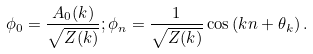Convert formula to latex. <formula><loc_0><loc_0><loc_500><loc_500>\phi _ { 0 } = \frac { A _ { 0 } ( k ) } { \sqrt { Z ( k ) } } ; \phi _ { n } = \frac { 1 } { \sqrt { Z ( k ) } } \cos \left ( k n + \theta _ { k } \right ) .</formula> 